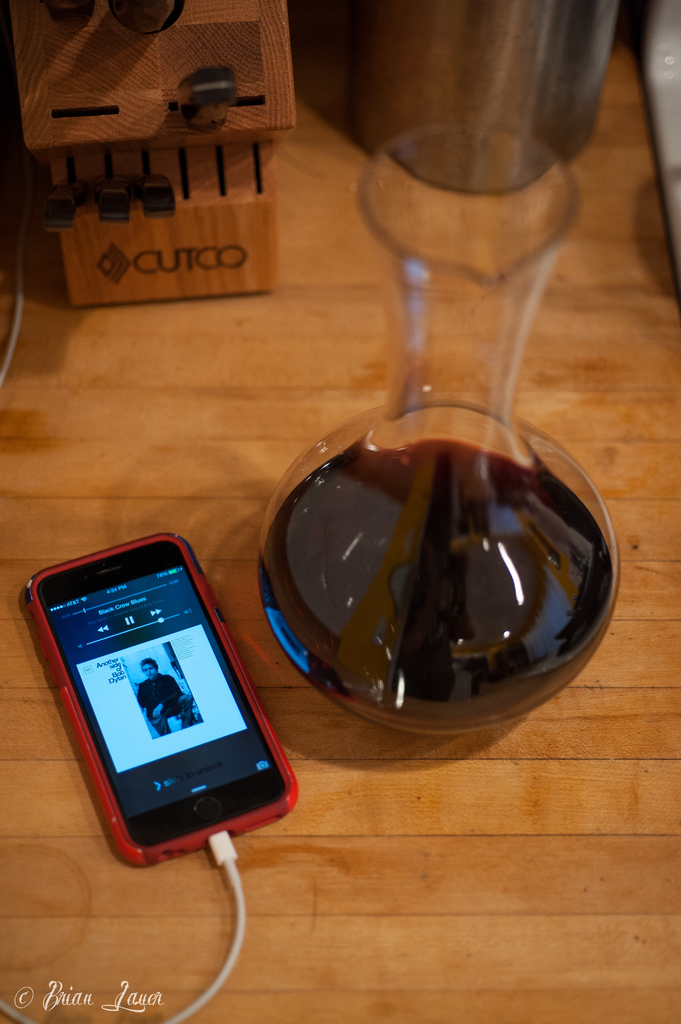What elements contribute to the cozy yet sleek aesthetic of this kitchen scene? The combination of wood textures, the warm glow of the lighting, and contemporary gadgets like the smartphone and modern wine decanter add both a cozy and sleek touch to the scene. 